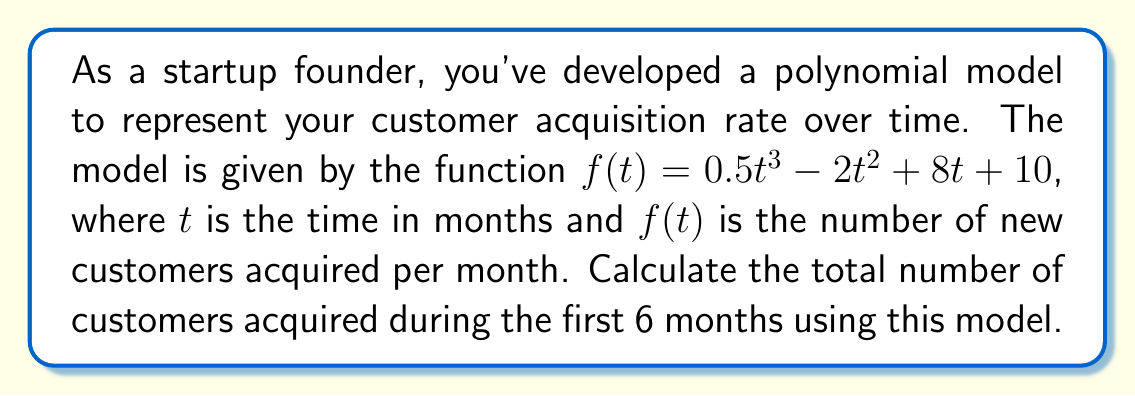Can you solve this math problem? To solve this problem, we need to calculate the area under the curve of the given polynomial function from $t=0$ to $t=6$. This can be done using definite integration.

1. Set up the definite integral:
   $$\int_{0}^{6} (0.5t^3 - 2t^2 + 8t + 10) dt$$

2. Integrate the polynomial term by term:
   $$\left[ \frac{0.5t^4}{4} - \frac{2t^3}{3} + 4t^2 + 10t \right]_{0}^{6}$$

3. Evaluate the integral at the upper and lower bounds:
   Upper bound (t=6):
   $$\frac{0.5(6^4)}{4} - \frac{2(6^3)}{3} + 4(6^2) + 10(6)$$
   $$= 324 - 144 + 144 + 60 = 384$$

   Lower bound (t=0):
   $$\frac{0.5(0^4)}{4} - \frac{2(0^3)}{3} + 4(0^2) + 10(0) = 0$$

4. Subtract the lower bound from the upper bound:
   $$384 - 0 = 384$$

Therefore, the total number of customers acquired during the first 6 months is 384.
Answer: 384 customers 